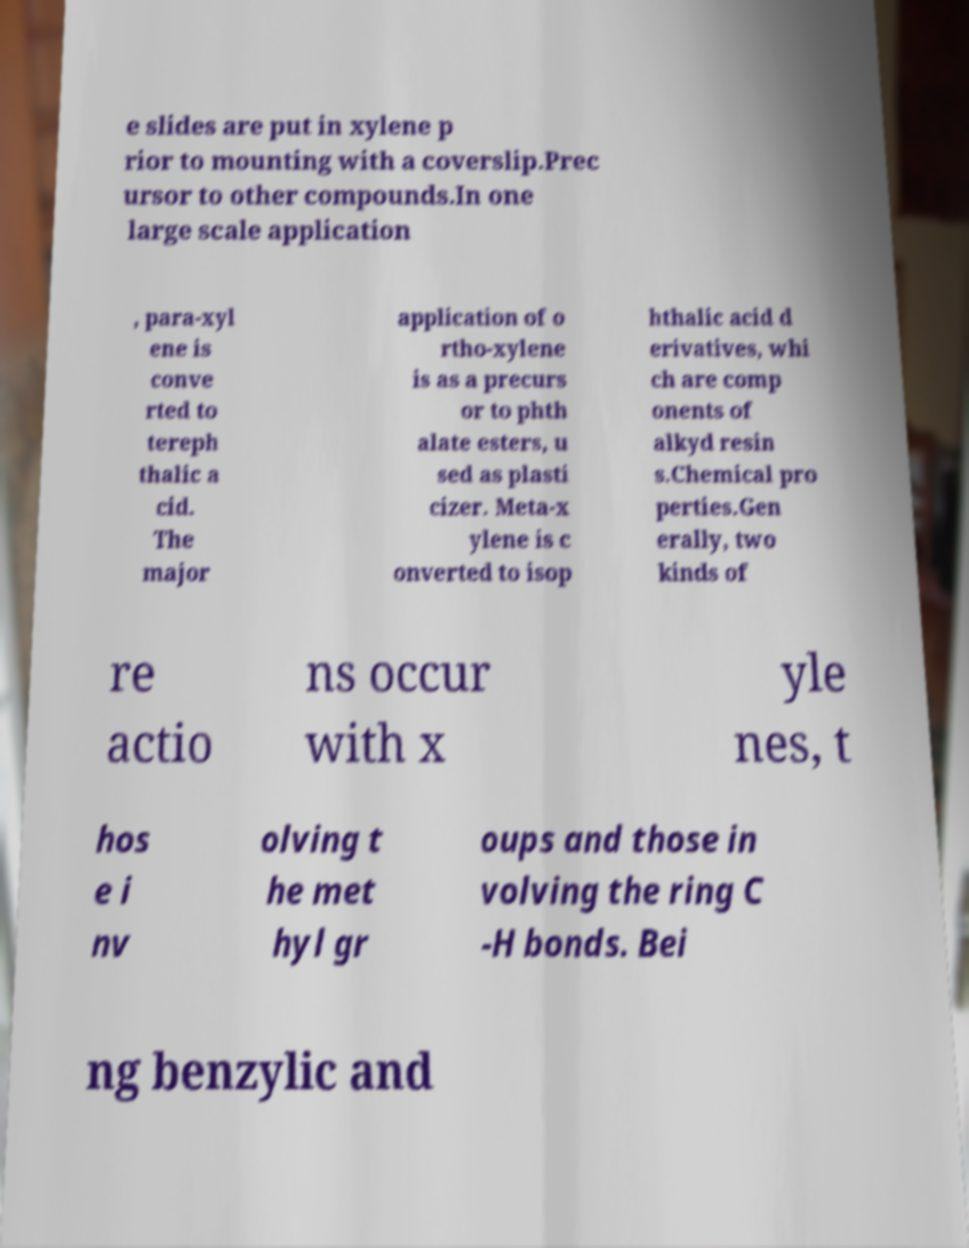For documentation purposes, I need the text within this image transcribed. Could you provide that? e slides are put in xylene p rior to mounting with a coverslip.Prec ursor to other compounds.In one large scale application , para-xyl ene is conve rted to tereph thalic a cid. The major application of o rtho-xylene is as a precurs or to phth alate esters, u sed as plasti cizer. Meta-x ylene is c onverted to isop hthalic acid d erivatives, whi ch are comp onents of alkyd resin s.Chemical pro perties.Gen erally, two kinds of re actio ns occur with x yle nes, t hos e i nv olving t he met hyl gr oups and those in volving the ring C -H bonds. Bei ng benzylic and 